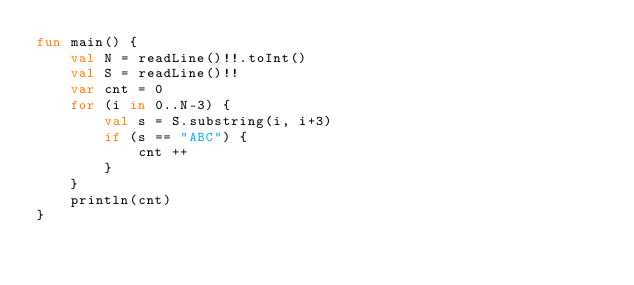Convert code to text. <code><loc_0><loc_0><loc_500><loc_500><_Kotlin_>fun main() {
    val N = readLine()!!.toInt()
    val S = readLine()!!
    var cnt = 0
    for (i in 0..N-3) {
        val s = S.substring(i, i+3)
        if (s == "ABC") {
            cnt ++
        }
    }
    println(cnt)
}</code> 